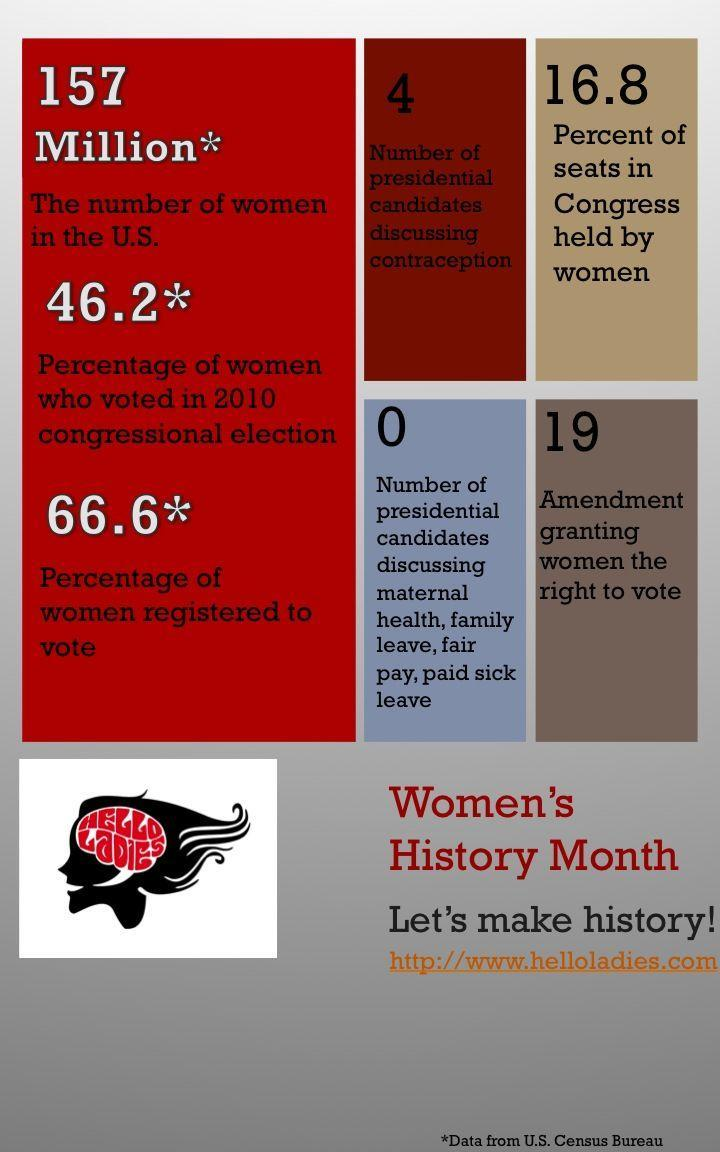What is the percentage of women registered to vote?
Answer the question with a short phrase. 66.6 How many presidential candidates are discussing contraception? 4 How many presidential candidates are discussing maternal health, fair pay, paid sick leave? 0 Which amendment granted women the right to vote in the US? 19 What is the percent of seats held in Congress by women? 16.8 What is the number of women in the US? 157 million 